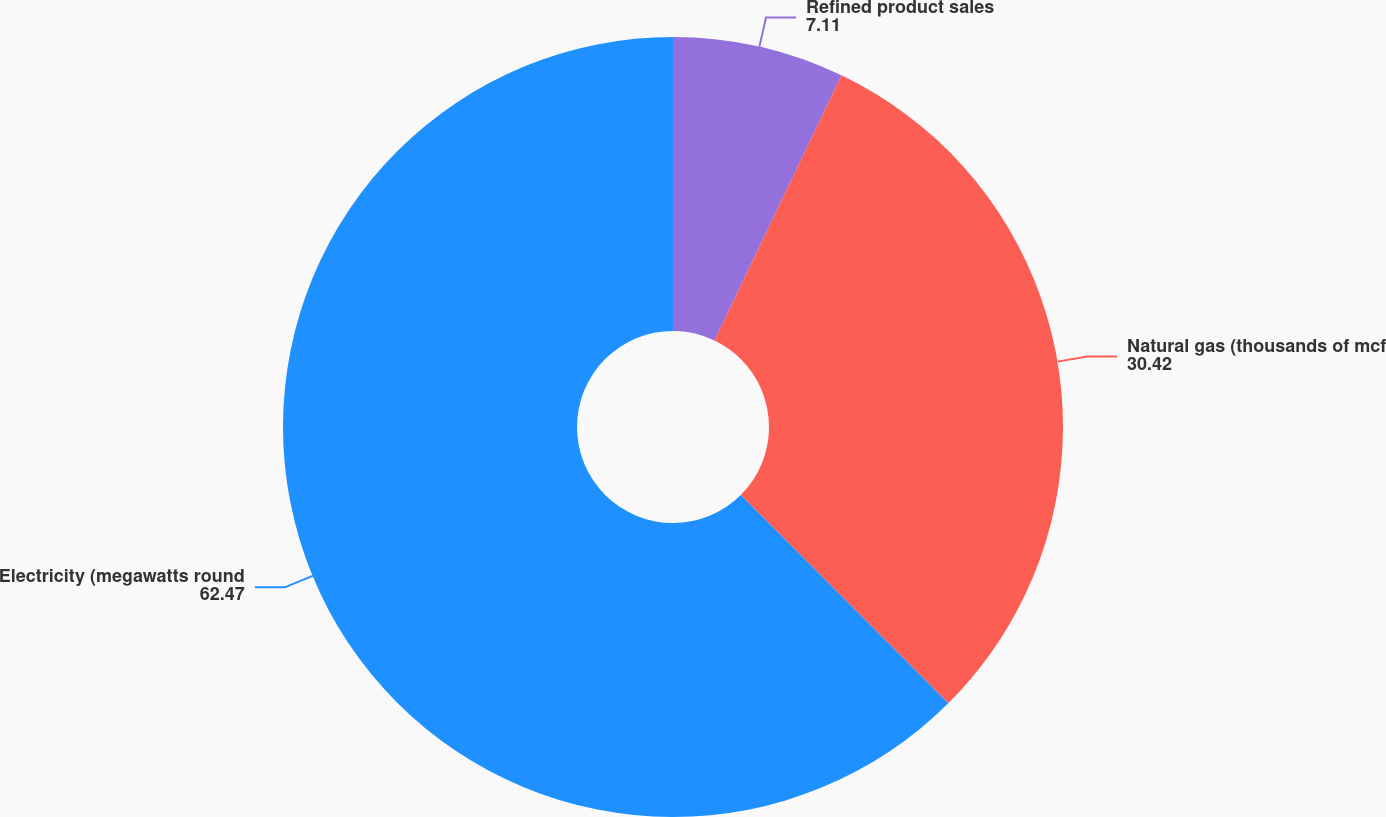Convert chart. <chart><loc_0><loc_0><loc_500><loc_500><pie_chart><fcel>Refined product sales<fcel>Natural gas (thousands of mcf<fcel>Electricity (megawatts round<nl><fcel>7.11%<fcel>30.42%<fcel>62.47%<nl></chart> 